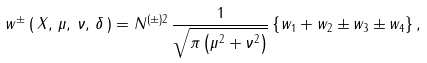Convert formula to latex. <formula><loc_0><loc_0><loc_500><loc_500>w ^ { \pm } \, ( \, X , \, \mu , \, \nu , \, \delta \, ) = N ^ { ( \pm ) 2 } \, \frac { 1 } { \sqrt { \pi \left ( \mu ^ { 2 } + \nu ^ { 2 } \right ) } } \left \{ w _ { 1 } + w _ { 2 } \pm w _ { 3 } \pm w _ { 4 } \right \} ,</formula> 